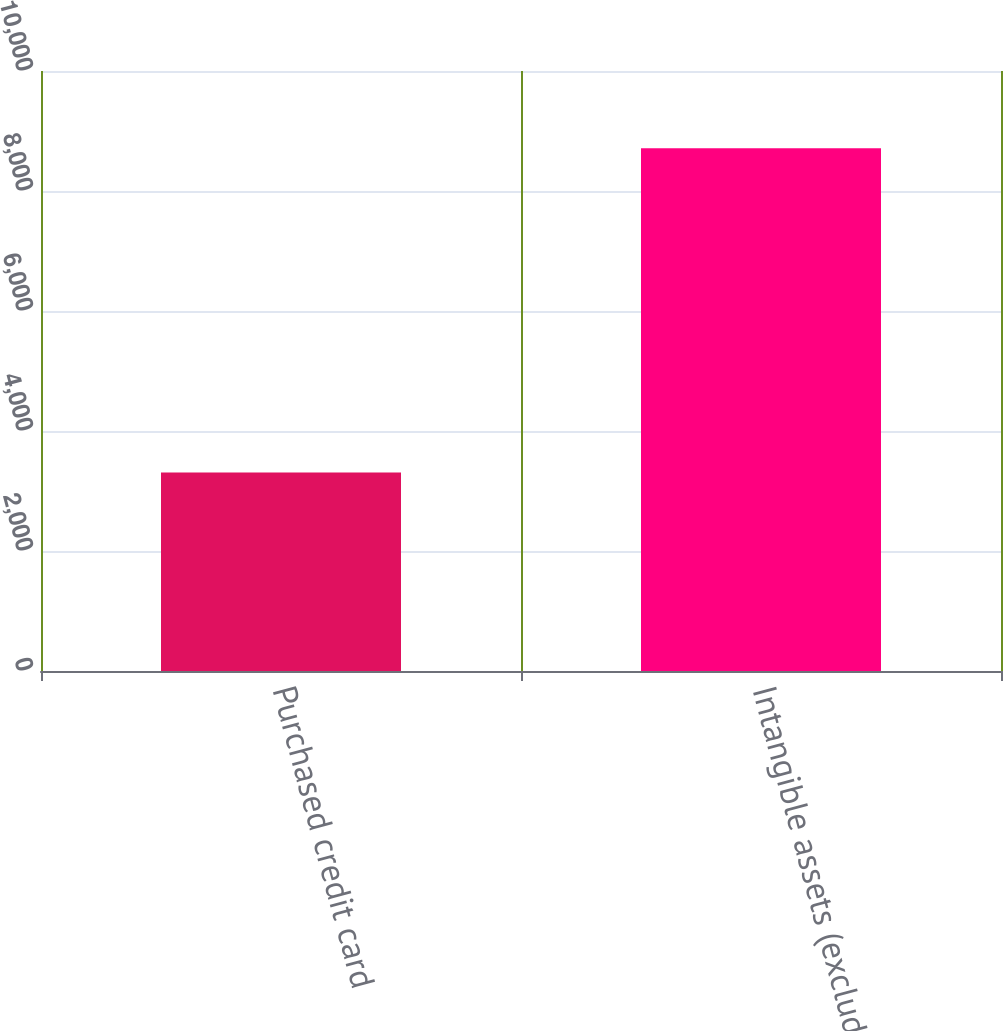Convert chart. <chart><loc_0><loc_0><loc_500><loc_500><bar_chart><fcel>Purchased credit card<fcel>Intangible assets (excluding<nl><fcel>3310<fcel>8714<nl></chart> 